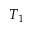Convert formula to latex. <formula><loc_0><loc_0><loc_500><loc_500>T _ { 1 }</formula> 